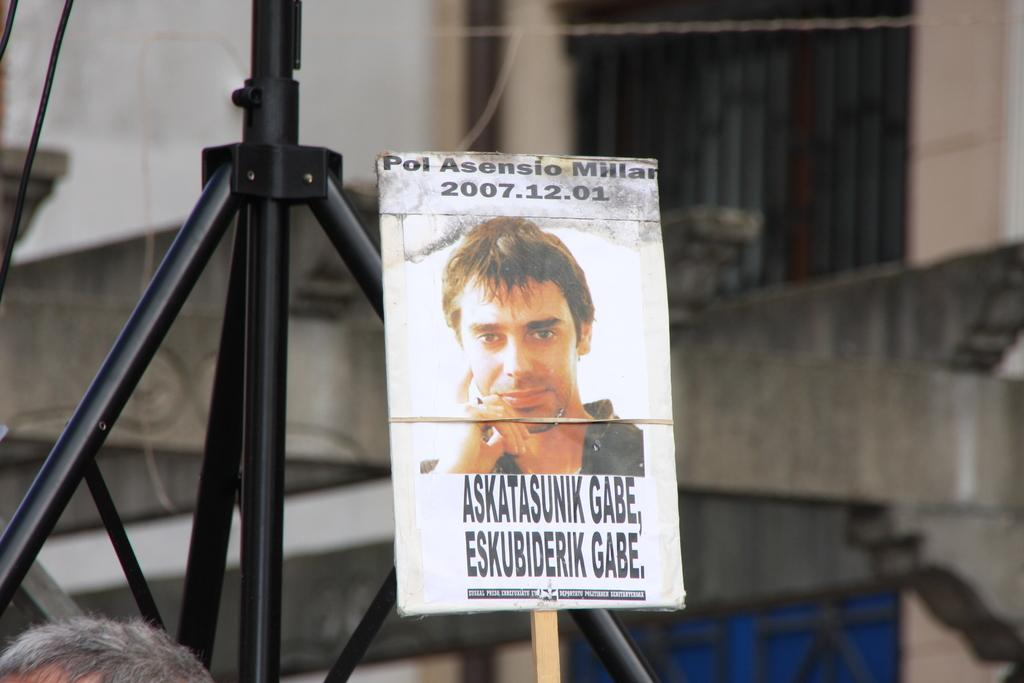What is the main subject of the image? The main subject of the image is a photograph. How is the photograph displayed in the image? The photograph is pasted on a placard. What type of powder is being used to decorate the wall in the image? There is no wall or powder present in the image; it only features a photograph pasted on a placard. 